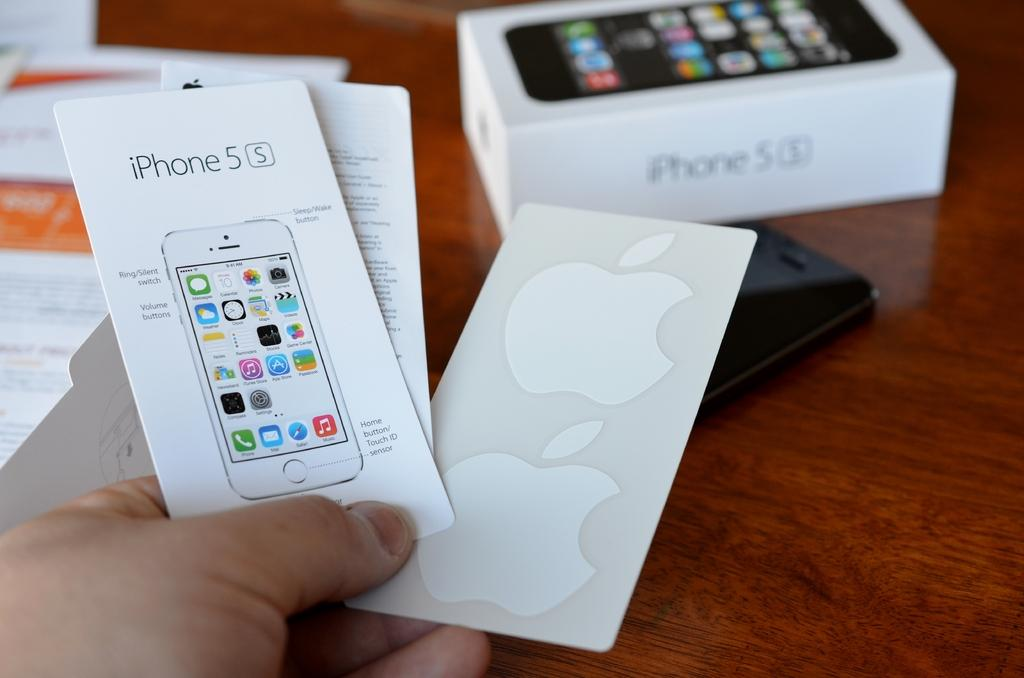<image>
Summarize the visual content of the image. a person holding an iPhone piece of paper 